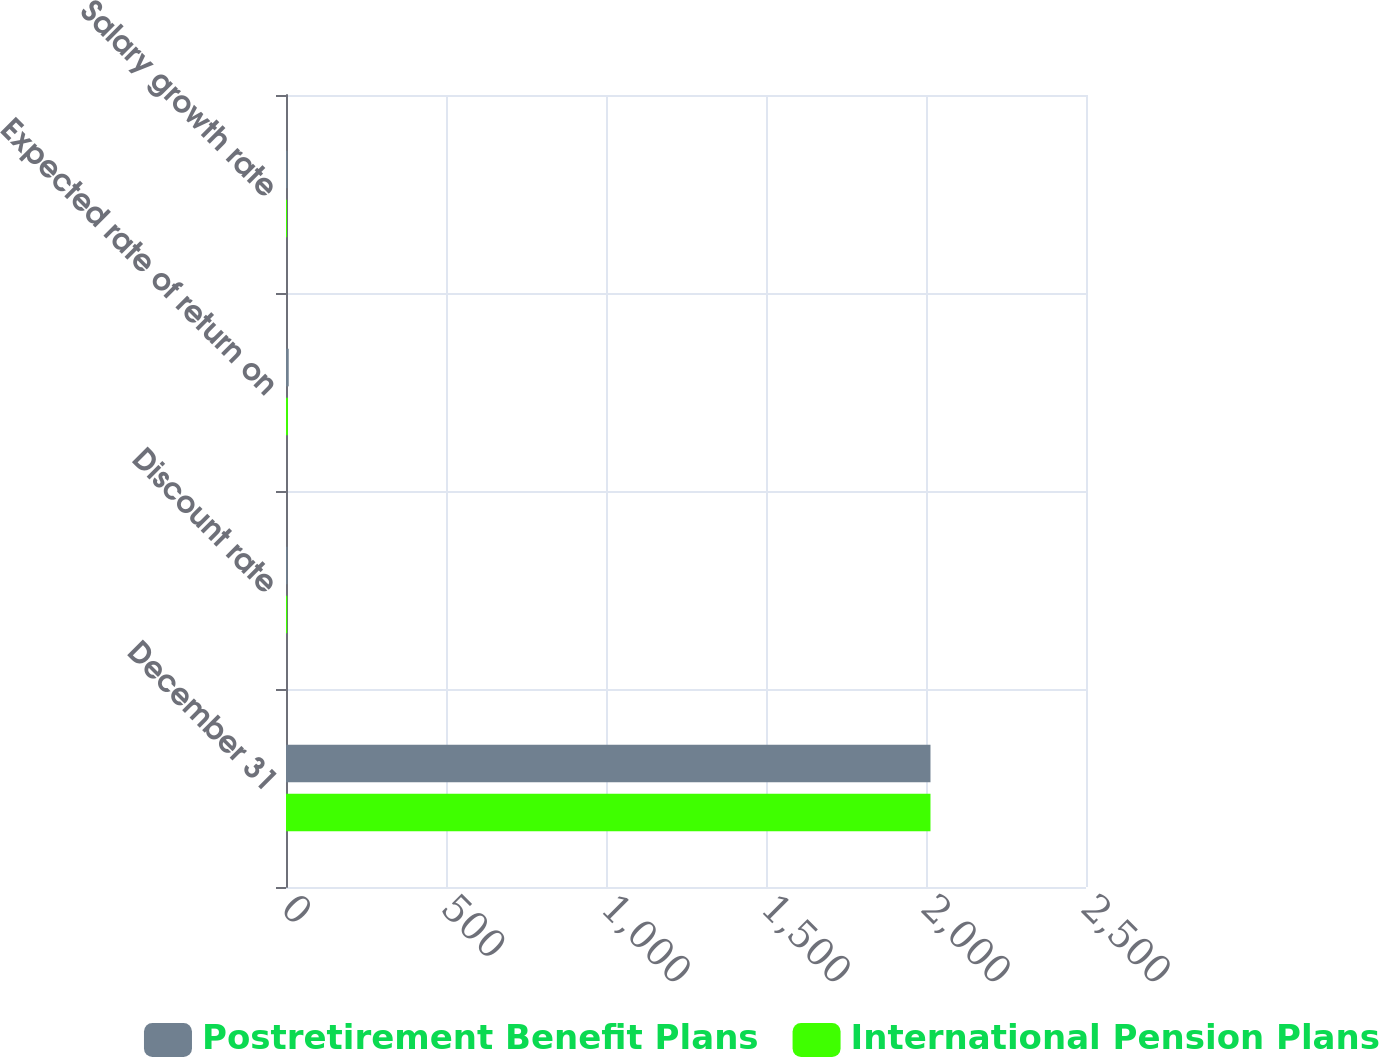Convert chart. <chart><loc_0><loc_0><loc_500><loc_500><stacked_bar_chart><ecel><fcel>December 31<fcel>Discount rate<fcel>Expected rate of return on<fcel>Salary growth rate<nl><fcel>Postretirement Benefit Plans<fcel>2014<fcel>4.9<fcel>8.5<fcel>4.5<nl><fcel>International Pension Plans<fcel>2014<fcel>3.8<fcel>6<fcel>3.1<nl></chart> 